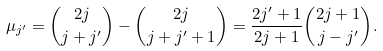Convert formula to latex. <formula><loc_0><loc_0><loc_500><loc_500>\mu _ { j ^ { \prime } } = { 2 j \choose { j + j ^ { \prime } } } - { 2 j \choose { j + j ^ { \prime } + 1 } } = \frac { 2 j ^ { \prime } + 1 } { 2 j + 1 } { { 2 j + 1 } \choose { j - j ^ { \prime } } } .</formula> 